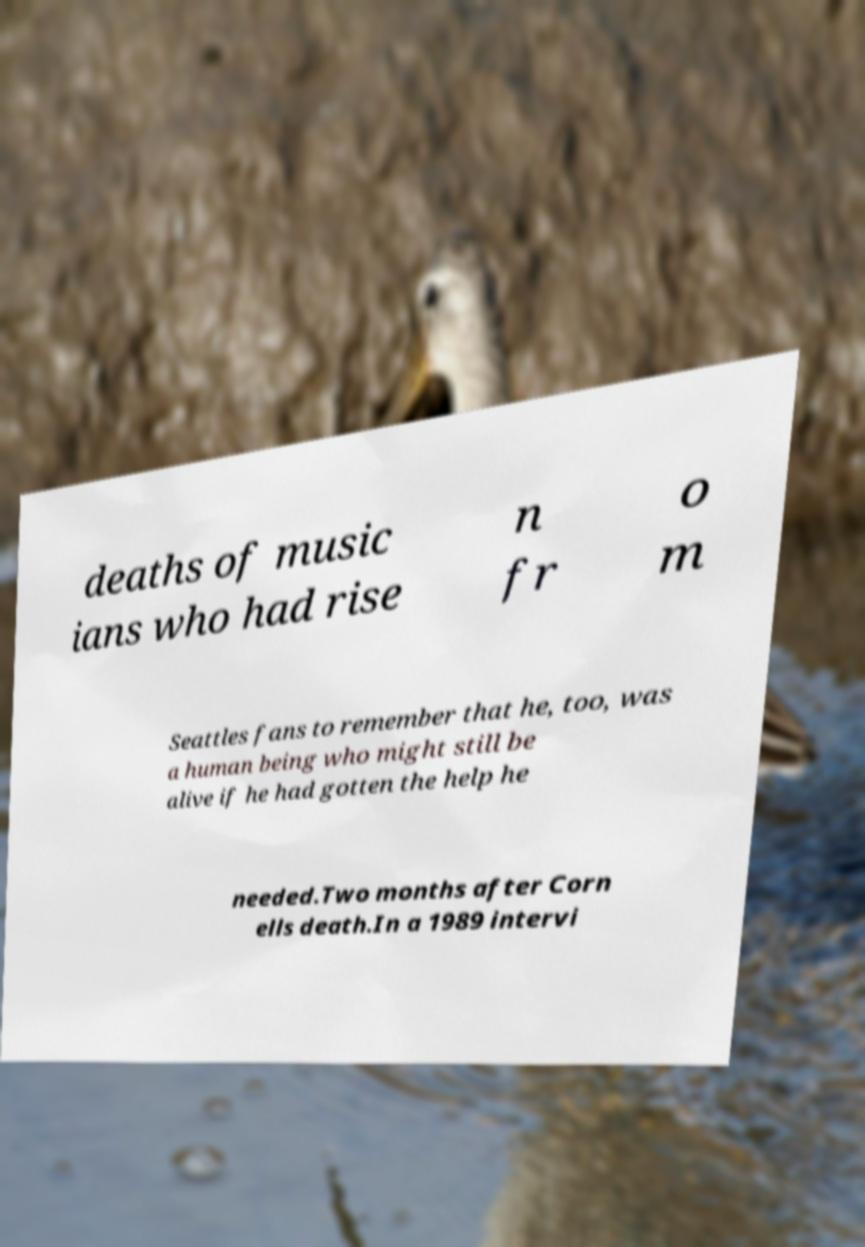Could you extract and type out the text from this image? deaths of music ians who had rise n fr o m Seattles fans to remember that he, too, was a human being who might still be alive if he had gotten the help he needed.Two months after Corn ells death.In a 1989 intervi 